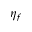<formula> <loc_0><loc_0><loc_500><loc_500>\eta _ { f }</formula> 